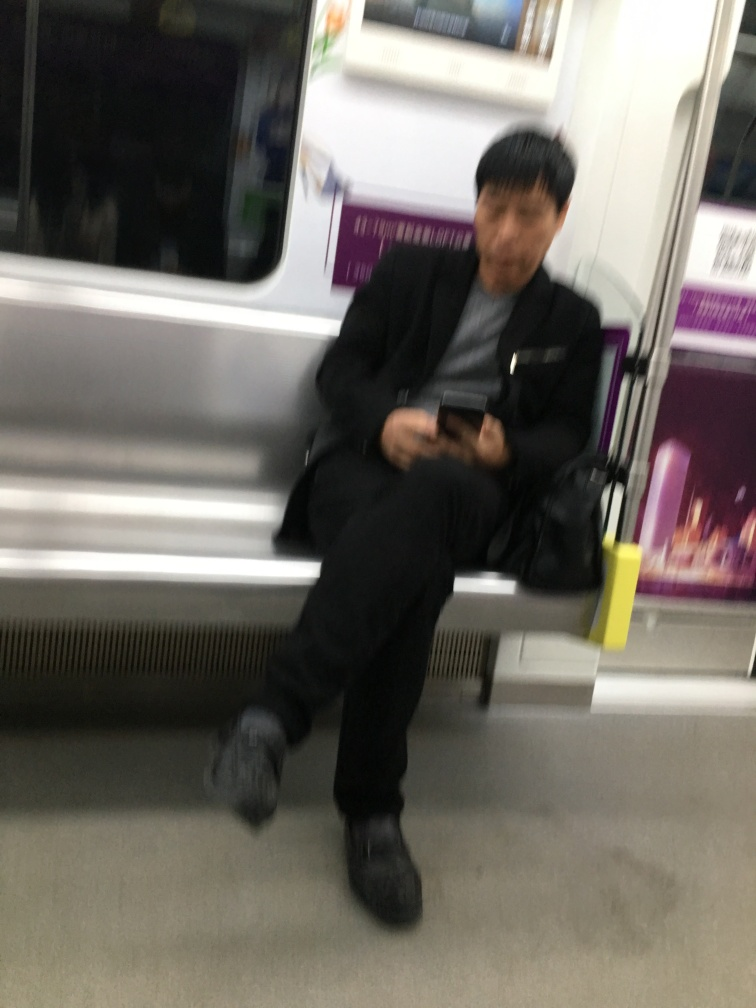What activities do you think are common in this image's setting? In settings like the one shown in the image, common activities would include passengers commuting, reading, using their mobile devices, listening to music through headphones, or simply resting during the journey. 